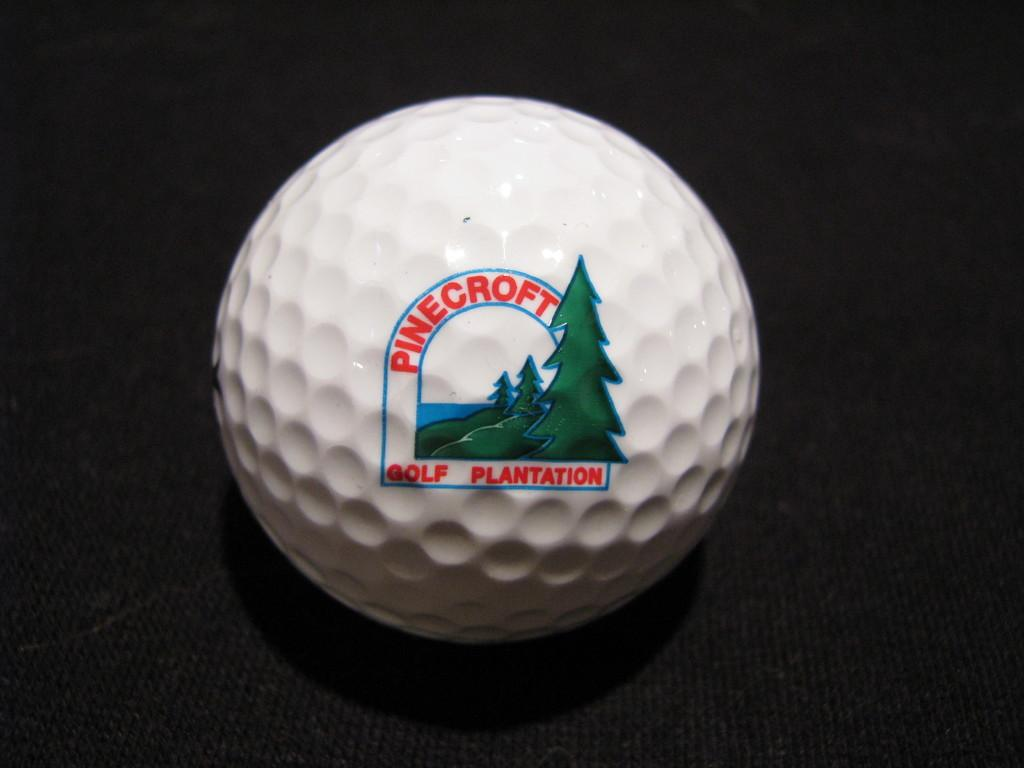Provide a one-sentence caption for the provided image. A golf ball from the Pinecroft Golf Plantation course. 